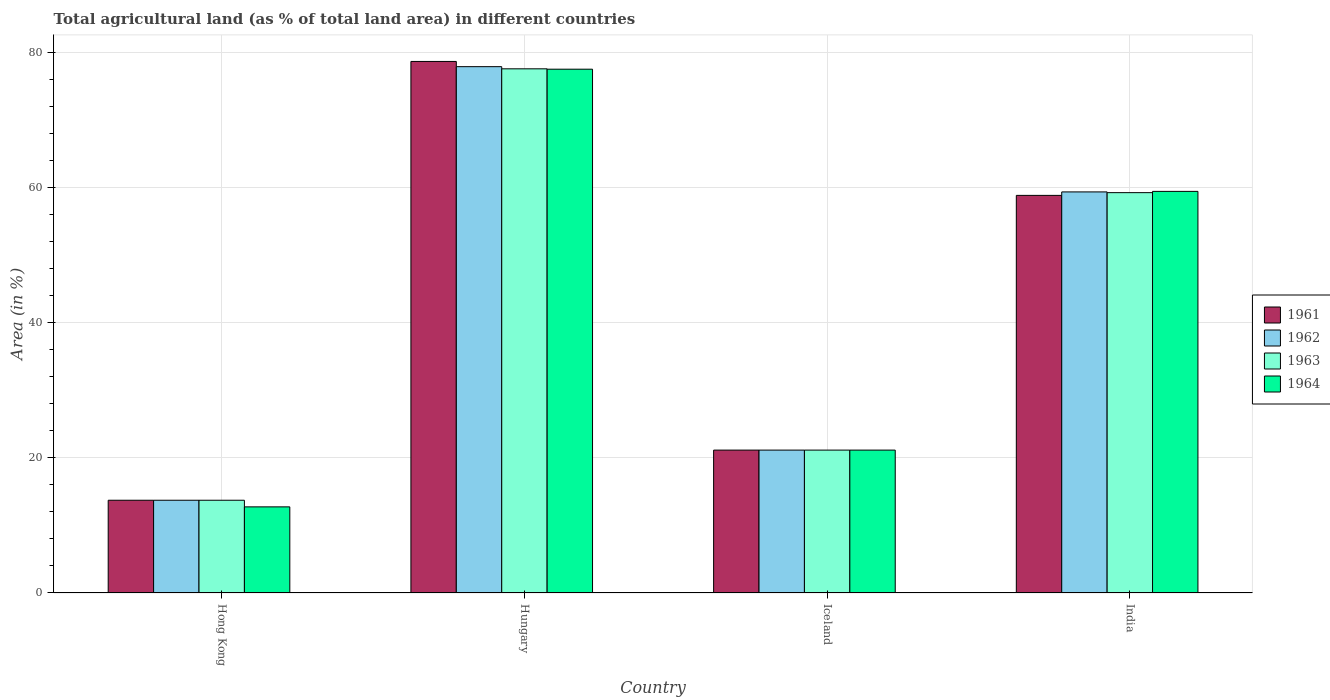How many groups of bars are there?
Your answer should be compact. 4. How many bars are there on the 1st tick from the left?
Your answer should be compact. 4. What is the label of the 4th group of bars from the left?
Give a very brief answer. India. What is the percentage of agricultural land in 1963 in Iceland?
Provide a succinct answer. 21.15. Across all countries, what is the maximum percentage of agricultural land in 1961?
Keep it short and to the point. 78.67. Across all countries, what is the minimum percentage of agricultural land in 1964?
Offer a very short reply. 12.75. In which country was the percentage of agricultural land in 1963 maximum?
Make the answer very short. Hungary. In which country was the percentage of agricultural land in 1961 minimum?
Provide a succinct answer. Hong Kong. What is the total percentage of agricultural land in 1962 in the graph?
Provide a succinct answer. 172.12. What is the difference between the percentage of agricultural land in 1961 in Hong Kong and that in Hungary?
Offer a very short reply. -64.94. What is the difference between the percentage of agricultural land in 1961 in Hong Kong and the percentage of agricultural land in 1962 in India?
Offer a very short reply. -45.63. What is the average percentage of agricultural land in 1962 per country?
Give a very brief answer. 43.03. What is the difference between the percentage of agricultural land of/in 1964 and percentage of agricultural land of/in 1962 in Iceland?
Provide a short and direct response. 0. What is the ratio of the percentage of agricultural land in 1964 in Hungary to that in India?
Offer a terse response. 1.3. Is the percentage of agricultural land in 1964 in Hong Kong less than that in Iceland?
Give a very brief answer. Yes. What is the difference between the highest and the second highest percentage of agricultural land in 1963?
Ensure brevity in your answer.  -38.1. What is the difference between the highest and the lowest percentage of agricultural land in 1964?
Your answer should be very brief. 64.77. Is the sum of the percentage of agricultural land in 1963 in Hong Kong and Hungary greater than the maximum percentage of agricultural land in 1962 across all countries?
Your answer should be very brief. Yes. Is it the case that in every country, the sum of the percentage of agricultural land in 1964 and percentage of agricultural land in 1963 is greater than the sum of percentage of agricultural land in 1962 and percentage of agricultural land in 1961?
Offer a terse response. No. What does the 1st bar from the right in Iceland represents?
Give a very brief answer. 1964. How many countries are there in the graph?
Provide a succinct answer. 4. Are the values on the major ticks of Y-axis written in scientific E-notation?
Make the answer very short. No. Does the graph contain any zero values?
Make the answer very short. No. Does the graph contain grids?
Offer a terse response. Yes. Where does the legend appear in the graph?
Give a very brief answer. Center right. How are the legend labels stacked?
Keep it short and to the point. Vertical. What is the title of the graph?
Provide a short and direct response. Total agricultural land (as % of total land area) in different countries. What is the label or title of the X-axis?
Ensure brevity in your answer.  Country. What is the label or title of the Y-axis?
Make the answer very short. Area (in %). What is the Area (in %) in 1961 in Hong Kong?
Make the answer very short. 13.73. What is the Area (in %) of 1962 in Hong Kong?
Your answer should be compact. 13.73. What is the Area (in %) of 1963 in Hong Kong?
Offer a very short reply. 13.73. What is the Area (in %) in 1964 in Hong Kong?
Ensure brevity in your answer.  12.75. What is the Area (in %) in 1961 in Hungary?
Provide a short and direct response. 78.67. What is the Area (in %) in 1962 in Hungary?
Ensure brevity in your answer.  77.89. What is the Area (in %) of 1963 in Hungary?
Make the answer very short. 77.57. What is the Area (in %) in 1964 in Hungary?
Keep it short and to the point. 77.52. What is the Area (in %) of 1961 in Iceland?
Make the answer very short. 21.15. What is the Area (in %) of 1962 in Iceland?
Provide a short and direct response. 21.15. What is the Area (in %) in 1963 in Iceland?
Ensure brevity in your answer.  21.15. What is the Area (in %) of 1964 in Iceland?
Give a very brief answer. 21.15. What is the Area (in %) of 1961 in India?
Provide a succinct answer. 58.84. What is the Area (in %) in 1962 in India?
Offer a very short reply. 59.36. What is the Area (in %) of 1963 in India?
Keep it short and to the point. 59.25. What is the Area (in %) in 1964 in India?
Provide a short and direct response. 59.44. Across all countries, what is the maximum Area (in %) in 1961?
Ensure brevity in your answer.  78.67. Across all countries, what is the maximum Area (in %) of 1962?
Keep it short and to the point. 77.89. Across all countries, what is the maximum Area (in %) of 1963?
Offer a terse response. 77.57. Across all countries, what is the maximum Area (in %) of 1964?
Make the answer very short. 77.52. Across all countries, what is the minimum Area (in %) in 1961?
Give a very brief answer. 13.73. Across all countries, what is the minimum Area (in %) in 1962?
Make the answer very short. 13.73. Across all countries, what is the minimum Area (in %) in 1963?
Give a very brief answer. 13.73. Across all countries, what is the minimum Area (in %) in 1964?
Your response must be concise. 12.75. What is the total Area (in %) of 1961 in the graph?
Make the answer very short. 172.38. What is the total Area (in %) in 1962 in the graph?
Make the answer very short. 172.12. What is the total Area (in %) in 1963 in the graph?
Your answer should be very brief. 171.69. What is the total Area (in %) of 1964 in the graph?
Your answer should be very brief. 170.85. What is the difference between the Area (in %) in 1961 in Hong Kong and that in Hungary?
Offer a very short reply. -64.94. What is the difference between the Area (in %) of 1962 in Hong Kong and that in Hungary?
Give a very brief answer. -64.17. What is the difference between the Area (in %) in 1963 in Hong Kong and that in Hungary?
Your answer should be compact. -63.85. What is the difference between the Area (in %) of 1964 in Hong Kong and that in Hungary?
Make the answer very short. -64.77. What is the difference between the Area (in %) of 1961 in Hong Kong and that in Iceland?
Give a very brief answer. -7.42. What is the difference between the Area (in %) in 1962 in Hong Kong and that in Iceland?
Provide a succinct answer. -7.42. What is the difference between the Area (in %) of 1963 in Hong Kong and that in Iceland?
Your answer should be compact. -7.42. What is the difference between the Area (in %) in 1964 in Hong Kong and that in Iceland?
Ensure brevity in your answer.  -8.4. What is the difference between the Area (in %) of 1961 in Hong Kong and that in India?
Your answer should be compact. -45.12. What is the difference between the Area (in %) of 1962 in Hong Kong and that in India?
Provide a succinct answer. -45.63. What is the difference between the Area (in %) of 1963 in Hong Kong and that in India?
Ensure brevity in your answer.  -45.52. What is the difference between the Area (in %) in 1964 in Hong Kong and that in India?
Keep it short and to the point. -46.69. What is the difference between the Area (in %) of 1961 in Hungary and that in Iceland?
Provide a succinct answer. 57.52. What is the difference between the Area (in %) in 1962 in Hungary and that in Iceland?
Your answer should be compact. 56.75. What is the difference between the Area (in %) in 1963 in Hungary and that in Iceland?
Keep it short and to the point. 56.43. What is the difference between the Area (in %) of 1964 in Hungary and that in Iceland?
Your answer should be compact. 56.37. What is the difference between the Area (in %) of 1961 in Hungary and that in India?
Make the answer very short. 19.82. What is the difference between the Area (in %) of 1962 in Hungary and that in India?
Offer a terse response. 18.54. What is the difference between the Area (in %) in 1963 in Hungary and that in India?
Make the answer very short. 18.33. What is the difference between the Area (in %) of 1964 in Hungary and that in India?
Your answer should be compact. 18.08. What is the difference between the Area (in %) in 1961 in Iceland and that in India?
Offer a very short reply. -37.7. What is the difference between the Area (in %) in 1962 in Iceland and that in India?
Provide a short and direct response. -38.21. What is the difference between the Area (in %) in 1963 in Iceland and that in India?
Provide a short and direct response. -38.1. What is the difference between the Area (in %) in 1964 in Iceland and that in India?
Your response must be concise. -38.29. What is the difference between the Area (in %) in 1961 in Hong Kong and the Area (in %) in 1962 in Hungary?
Provide a short and direct response. -64.17. What is the difference between the Area (in %) of 1961 in Hong Kong and the Area (in %) of 1963 in Hungary?
Give a very brief answer. -63.85. What is the difference between the Area (in %) in 1961 in Hong Kong and the Area (in %) in 1964 in Hungary?
Ensure brevity in your answer.  -63.79. What is the difference between the Area (in %) of 1962 in Hong Kong and the Area (in %) of 1963 in Hungary?
Ensure brevity in your answer.  -63.85. What is the difference between the Area (in %) in 1962 in Hong Kong and the Area (in %) in 1964 in Hungary?
Your answer should be very brief. -63.79. What is the difference between the Area (in %) of 1963 in Hong Kong and the Area (in %) of 1964 in Hungary?
Give a very brief answer. -63.79. What is the difference between the Area (in %) in 1961 in Hong Kong and the Area (in %) in 1962 in Iceland?
Provide a succinct answer. -7.42. What is the difference between the Area (in %) of 1961 in Hong Kong and the Area (in %) of 1963 in Iceland?
Offer a terse response. -7.42. What is the difference between the Area (in %) in 1961 in Hong Kong and the Area (in %) in 1964 in Iceland?
Your answer should be compact. -7.42. What is the difference between the Area (in %) of 1962 in Hong Kong and the Area (in %) of 1963 in Iceland?
Provide a short and direct response. -7.42. What is the difference between the Area (in %) of 1962 in Hong Kong and the Area (in %) of 1964 in Iceland?
Your answer should be very brief. -7.42. What is the difference between the Area (in %) of 1963 in Hong Kong and the Area (in %) of 1964 in Iceland?
Your answer should be compact. -7.42. What is the difference between the Area (in %) in 1961 in Hong Kong and the Area (in %) in 1962 in India?
Provide a succinct answer. -45.63. What is the difference between the Area (in %) of 1961 in Hong Kong and the Area (in %) of 1963 in India?
Your response must be concise. -45.52. What is the difference between the Area (in %) of 1961 in Hong Kong and the Area (in %) of 1964 in India?
Make the answer very short. -45.71. What is the difference between the Area (in %) in 1962 in Hong Kong and the Area (in %) in 1963 in India?
Your response must be concise. -45.52. What is the difference between the Area (in %) of 1962 in Hong Kong and the Area (in %) of 1964 in India?
Your answer should be compact. -45.71. What is the difference between the Area (in %) of 1963 in Hong Kong and the Area (in %) of 1964 in India?
Make the answer very short. -45.71. What is the difference between the Area (in %) of 1961 in Hungary and the Area (in %) of 1962 in Iceland?
Your answer should be compact. 57.52. What is the difference between the Area (in %) of 1961 in Hungary and the Area (in %) of 1963 in Iceland?
Your answer should be very brief. 57.52. What is the difference between the Area (in %) in 1961 in Hungary and the Area (in %) in 1964 in Iceland?
Provide a succinct answer. 57.52. What is the difference between the Area (in %) in 1962 in Hungary and the Area (in %) in 1963 in Iceland?
Give a very brief answer. 56.75. What is the difference between the Area (in %) of 1962 in Hungary and the Area (in %) of 1964 in Iceland?
Your response must be concise. 56.75. What is the difference between the Area (in %) in 1963 in Hungary and the Area (in %) in 1964 in Iceland?
Ensure brevity in your answer.  56.43. What is the difference between the Area (in %) of 1961 in Hungary and the Area (in %) of 1962 in India?
Give a very brief answer. 19.31. What is the difference between the Area (in %) in 1961 in Hungary and the Area (in %) in 1963 in India?
Give a very brief answer. 19.42. What is the difference between the Area (in %) in 1961 in Hungary and the Area (in %) in 1964 in India?
Ensure brevity in your answer.  19.23. What is the difference between the Area (in %) in 1962 in Hungary and the Area (in %) in 1963 in India?
Offer a terse response. 18.65. What is the difference between the Area (in %) of 1962 in Hungary and the Area (in %) of 1964 in India?
Offer a terse response. 18.46. What is the difference between the Area (in %) in 1963 in Hungary and the Area (in %) in 1964 in India?
Your answer should be very brief. 18.14. What is the difference between the Area (in %) in 1961 in Iceland and the Area (in %) in 1962 in India?
Offer a terse response. -38.21. What is the difference between the Area (in %) in 1961 in Iceland and the Area (in %) in 1963 in India?
Your answer should be very brief. -38.1. What is the difference between the Area (in %) in 1961 in Iceland and the Area (in %) in 1964 in India?
Give a very brief answer. -38.29. What is the difference between the Area (in %) of 1962 in Iceland and the Area (in %) of 1963 in India?
Give a very brief answer. -38.1. What is the difference between the Area (in %) in 1962 in Iceland and the Area (in %) in 1964 in India?
Your answer should be compact. -38.29. What is the difference between the Area (in %) in 1963 in Iceland and the Area (in %) in 1964 in India?
Your answer should be very brief. -38.29. What is the average Area (in %) in 1961 per country?
Give a very brief answer. 43.1. What is the average Area (in %) in 1962 per country?
Your answer should be compact. 43.03. What is the average Area (in %) in 1963 per country?
Keep it short and to the point. 42.92. What is the average Area (in %) in 1964 per country?
Offer a very short reply. 42.71. What is the difference between the Area (in %) in 1961 and Area (in %) in 1962 in Hong Kong?
Give a very brief answer. 0. What is the difference between the Area (in %) of 1961 and Area (in %) of 1964 in Hong Kong?
Your answer should be compact. 0.98. What is the difference between the Area (in %) in 1962 and Area (in %) in 1963 in Hong Kong?
Offer a very short reply. 0. What is the difference between the Area (in %) of 1962 and Area (in %) of 1964 in Hong Kong?
Ensure brevity in your answer.  0.98. What is the difference between the Area (in %) of 1963 and Area (in %) of 1964 in Hong Kong?
Give a very brief answer. 0.98. What is the difference between the Area (in %) in 1961 and Area (in %) in 1962 in Hungary?
Keep it short and to the point. 0.77. What is the difference between the Area (in %) of 1961 and Area (in %) of 1964 in Hungary?
Ensure brevity in your answer.  1.15. What is the difference between the Area (in %) in 1962 and Area (in %) in 1963 in Hungary?
Offer a very short reply. 0.32. What is the difference between the Area (in %) of 1962 and Area (in %) of 1964 in Hungary?
Provide a succinct answer. 0.38. What is the difference between the Area (in %) of 1963 and Area (in %) of 1964 in Hungary?
Give a very brief answer. 0.06. What is the difference between the Area (in %) of 1961 and Area (in %) of 1964 in Iceland?
Offer a very short reply. 0. What is the difference between the Area (in %) of 1961 and Area (in %) of 1962 in India?
Make the answer very short. -0.51. What is the difference between the Area (in %) of 1961 and Area (in %) of 1963 in India?
Your answer should be very brief. -0.4. What is the difference between the Area (in %) of 1961 and Area (in %) of 1964 in India?
Provide a short and direct response. -0.59. What is the difference between the Area (in %) in 1962 and Area (in %) in 1963 in India?
Make the answer very short. 0.11. What is the difference between the Area (in %) of 1962 and Area (in %) of 1964 in India?
Offer a very short reply. -0.08. What is the difference between the Area (in %) in 1963 and Area (in %) in 1964 in India?
Your answer should be very brief. -0.19. What is the ratio of the Area (in %) of 1961 in Hong Kong to that in Hungary?
Keep it short and to the point. 0.17. What is the ratio of the Area (in %) in 1962 in Hong Kong to that in Hungary?
Give a very brief answer. 0.18. What is the ratio of the Area (in %) of 1963 in Hong Kong to that in Hungary?
Offer a very short reply. 0.18. What is the ratio of the Area (in %) in 1964 in Hong Kong to that in Hungary?
Offer a terse response. 0.16. What is the ratio of the Area (in %) of 1961 in Hong Kong to that in Iceland?
Your answer should be compact. 0.65. What is the ratio of the Area (in %) in 1962 in Hong Kong to that in Iceland?
Provide a short and direct response. 0.65. What is the ratio of the Area (in %) of 1963 in Hong Kong to that in Iceland?
Provide a short and direct response. 0.65. What is the ratio of the Area (in %) of 1964 in Hong Kong to that in Iceland?
Give a very brief answer. 0.6. What is the ratio of the Area (in %) of 1961 in Hong Kong to that in India?
Ensure brevity in your answer.  0.23. What is the ratio of the Area (in %) in 1962 in Hong Kong to that in India?
Your answer should be very brief. 0.23. What is the ratio of the Area (in %) in 1963 in Hong Kong to that in India?
Provide a succinct answer. 0.23. What is the ratio of the Area (in %) in 1964 in Hong Kong to that in India?
Keep it short and to the point. 0.21. What is the ratio of the Area (in %) of 1961 in Hungary to that in Iceland?
Your response must be concise. 3.72. What is the ratio of the Area (in %) of 1962 in Hungary to that in Iceland?
Your answer should be very brief. 3.68. What is the ratio of the Area (in %) of 1963 in Hungary to that in Iceland?
Provide a short and direct response. 3.67. What is the ratio of the Area (in %) in 1964 in Hungary to that in Iceland?
Ensure brevity in your answer.  3.67. What is the ratio of the Area (in %) in 1961 in Hungary to that in India?
Offer a terse response. 1.34. What is the ratio of the Area (in %) of 1962 in Hungary to that in India?
Offer a terse response. 1.31. What is the ratio of the Area (in %) of 1963 in Hungary to that in India?
Offer a terse response. 1.31. What is the ratio of the Area (in %) of 1964 in Hungary to that in India?
Your answer should be compact. 1.3. What is the ratio of the Area (in %) in 1961 in Iceland to that in India?
Provide a short and direct response. 0.36. What is the ratio of the Area (in %) of 1962 in Iceland to that in India?
Provide a short and direct response. 0.36. What is the ratio of the Area (in %) of 1963 in Iceland to that in India?
Your answer should be compact. 0.36. What is the ratio of the Area (in %) in 1964 in Iceland to that in India?
Provide a short and direct response. 0.36. What is the difference between the highest and the second highest Area (in %) in 1961?
Offer a very short reply. 19.82. What is the difference between the highest and the second highest Area (in %) in 1962?
Make the answer very short. 18.54. What is the difference between the highest and the second highest Area (in %) in 1963?
Your answer should be very brief. 18.33. What is the difference between the highest and the second highest Area (in %) in 1964?
Offer a very short reply. 18.08. What is the difference between the highest and the lowest Area (in %) in 1961?
Make the answer very short. 64.94. What is the difference between the highest and the lowest Area (in %) in 1962?
Keep it short and to the point. 64.17. What is the difference between the highest and the lowest Area (in %) in 1963?
Your response must be concise. 63.85. What is the difference between the highest and the lowest Area (in %) of 1964?
Your response must be concise. 64.77. 